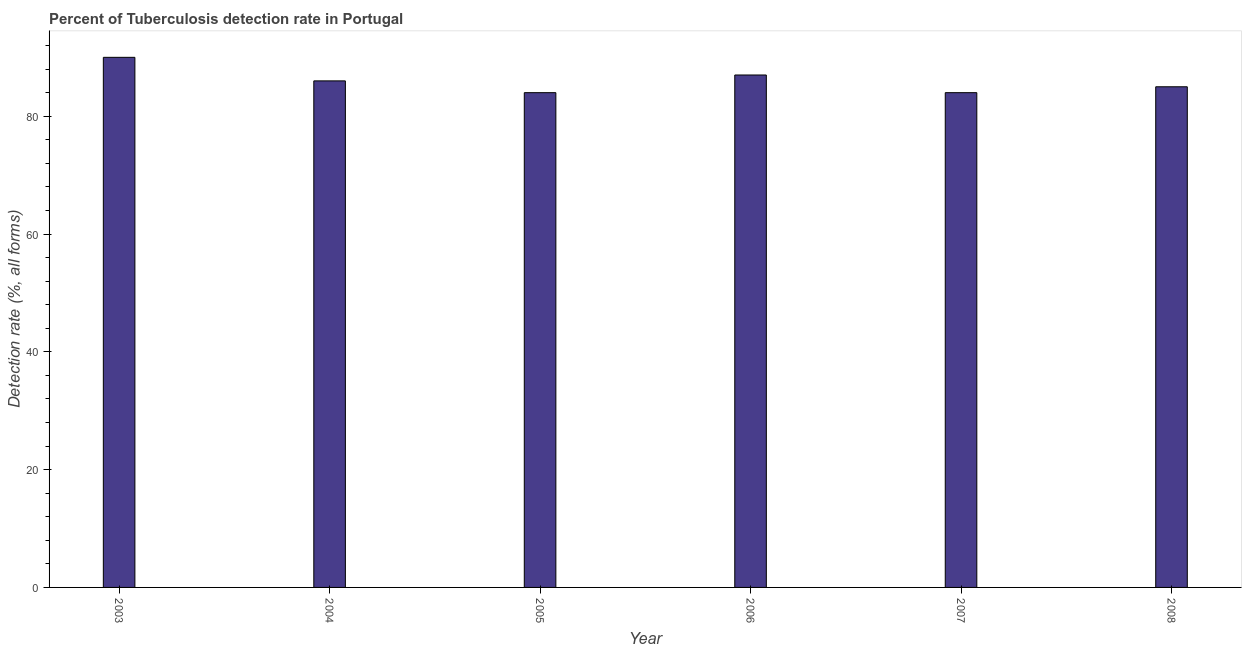Does the graph contain grids?
Offer a terse response. No. What is the title of the graph?
Your answer should be compact. Percent of Tuberculosis detection rate in Portugal. What is the label or title of the X-axis?
Offer a very short reply. Year. What is the label or title of the Y-axis?
Provide a succinct answer. Detection rate (%, all forms). Across all years, what is the maximum detection rate of tuberculosis?
Your response must be concise. 90. In which year was the detection rate of tuberculosis minimum?
Your answer should be compact. 2005. What is the sum of the detection rate of tuberculosis?
Provide a succinct answer. 516. What is the average detection rate of tuberculosis per year?
Ensure brevity in your answer.  86. What is the median detection rate of tuberculosis?
Give a very brief answer. 85.5. In how many years, is the detection rate of tuberculosis greater than 32 %?
Make the answer very short. 6. What is the ratio of the detection rate of tuberculosis in 2003 to that in 2004?
Provide a short and direct response. 1.05. Is the difference between the detection rate of tuberculosis in 2005 and 2006 greater than the difference between any two years?
Offer a terse response. No. What is the difference between the highest and the second highest detection rate of tuberculosis?
Provide a short and direct response. 3. Is the sum of the detection rate of tuberculosis in 2003 and 2005 greater than the maximum detection rate of tuberculosis across all years?
Your answer should be compact. Yes. Are all the bars in the graph horizontal?
Your response must be concise. No. How many years are there in the graph?
Offer a very short reply. 6. What is the Detection rate (%, all forms) of 2003?
Your response must be concise. 90. What is the Detection rate (%, all forms) in 2004?
Your answer should be compact. 86. What is the Detection rate (%, all forms) in 2006?
Ensure brevity in your answer.  87. What is the Detection rate (%, all forms) of 2007?
Your response must be concise. 84. What is the Detection rate (%, all forms) in 2008?
Provide a short and direct response. 85. What is the difference between the Detection rate (%, all forms) in 2003 and 2008?
Keep it short and to the point. 5. What is the difference between the Detection rate (%, all forms) in 2004 and 2006?
Give a very brief answer. -1. What is the difference between the Detection rate (%, all forms) in 2004 and 2007?
Offer a terse response. 2. What is the difference between the Detection rate (%, all forms) in 2004 and 2008?
Provide a short and direct response. 1. What is the difference between the Detection rate (%, all forms) in 2005 and 2007?
Your response must be concise. 0. What is the difference between the Detection rate (%, all forms) in 2006 and 2008?
Offer a terse response. 2. What is the ratio of the Detection rate (%, all forms) in 2003 to that in 2004?
Offer a terse response. 1.05. What is the ratio of the Detection rate (%, all forms) in 2003 to that in 2005?
Ensure brevity in your answer.  1.07. What is the ratio of the Detection rate (%, all forms) in 2003 to that in 2006?
Give a very brief answer. 1.03. What is the ratio of the Detection rate (%, all forms) in 2003 to that in 2007?
Your response must be concise. 1.07. What is the ratio of the Detection rate (%, all forms) in 2003 to that in 2008?
Make the answer very short. 1.06. What is the ratio of the Detection rate (%, all forms) in 2004 to that in 2006?
Your answer should be very brief. 0.99. What is the ratio of the Detection rate (%, all forms) in 2004 to that in 2008?
Keep it short and to the point. 1.01. What is the ratio of the Detection rate (%, all forms) in 2005 to that in 2006?
Give a very brief answer. 0.97. What is the ratio of the Detection rate (%, all forms) in 2006 to that in 2007?
Make the answer very short. 1.04. 